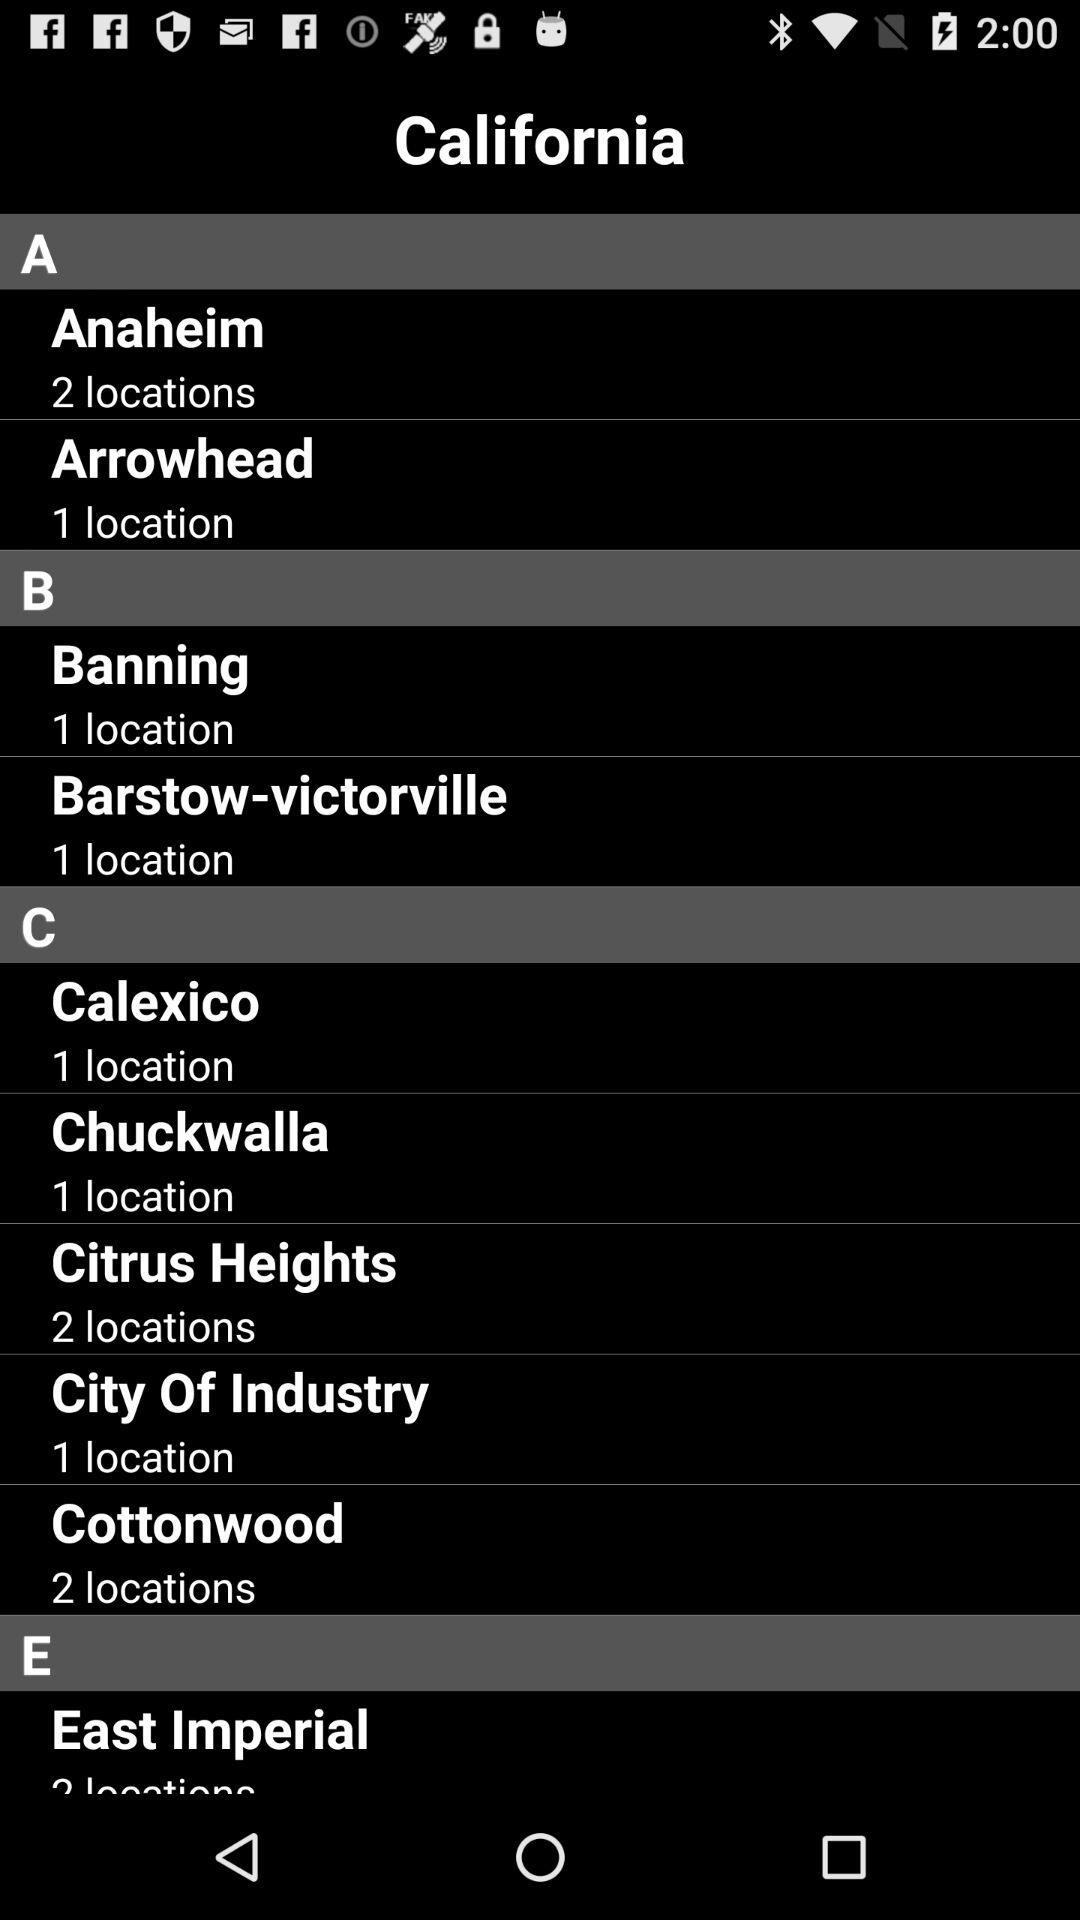How many locations are there in "Banning"? There is 1 location in "Banning". 